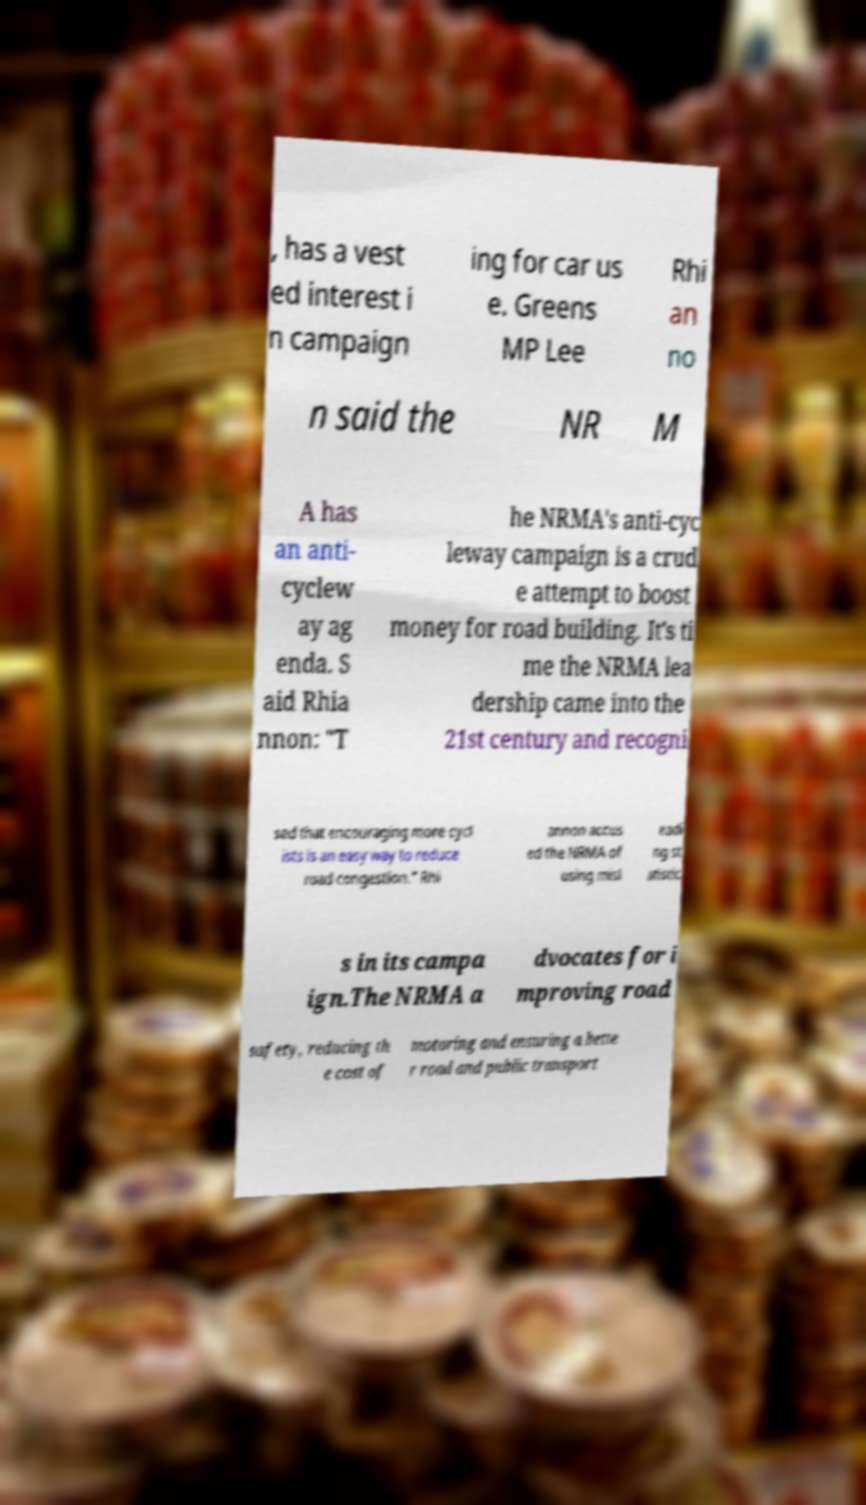Please identify and transcribe the text found in this image. , has a vest ed interest i n campaign ing for car us e. Greens MP Lee Rhi an no n said the NR M A has an anti- cyclew ay ag enda. S aid Rhia nnon: "T he NRMA's anti-cyc leway campaign is a crud e attempt to boost money for road building. It's ti me the NRMA lea dership came into the 21st century and recogni sed that encouraging more cycl ists is an easy way to reduce road congestion." Rhi annon accus ed the NRMA of using misl eadi ng st atistic s in its campa ign.The NRMA a dvocates for i mproving road safety, reducing th e cost of motoring and ensuring a bette r road and public transport 